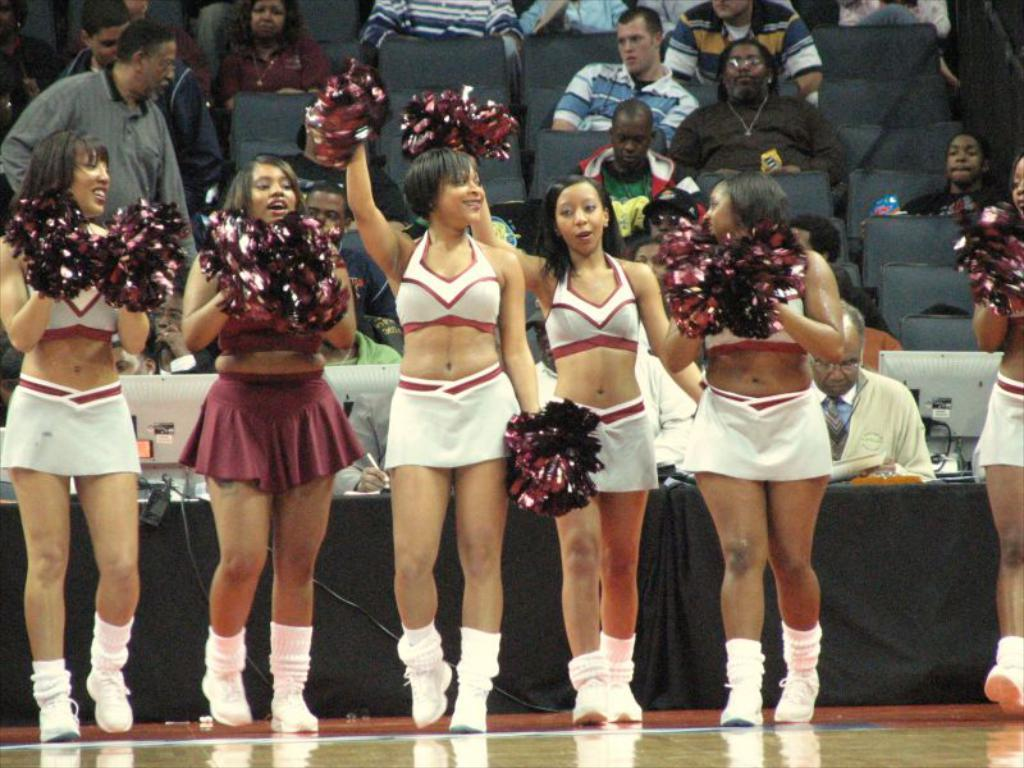What is the main subject of the image? The main subject of the image is women standing. What are the women wearing in the image? The women are wearing white and maroon color dresses. Can you describe the people in the background of the image? There are people sitting in chairs in the background of the image. What type of hose is being used by the mother in the image? There is no mother or hose present in the image. How many clocks can be seen on the wall in the image? There are no clocks visible on the wall in the image. 